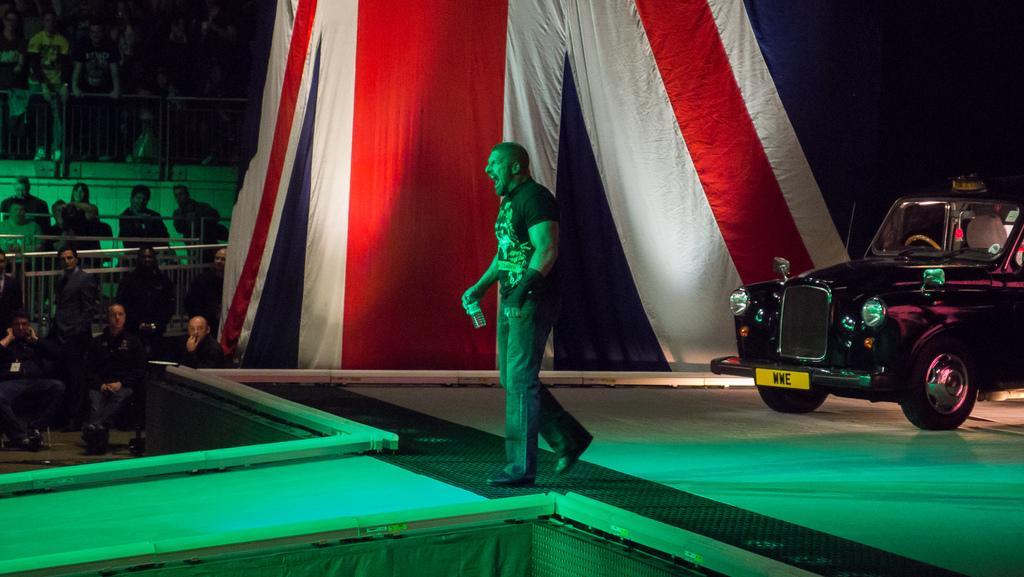How would you summarize this image in a sentence or two? In this image we can see a man walking on the stage holding a bottle. We can also see a car beside him. On the left side we can see a group of people and the fence. 